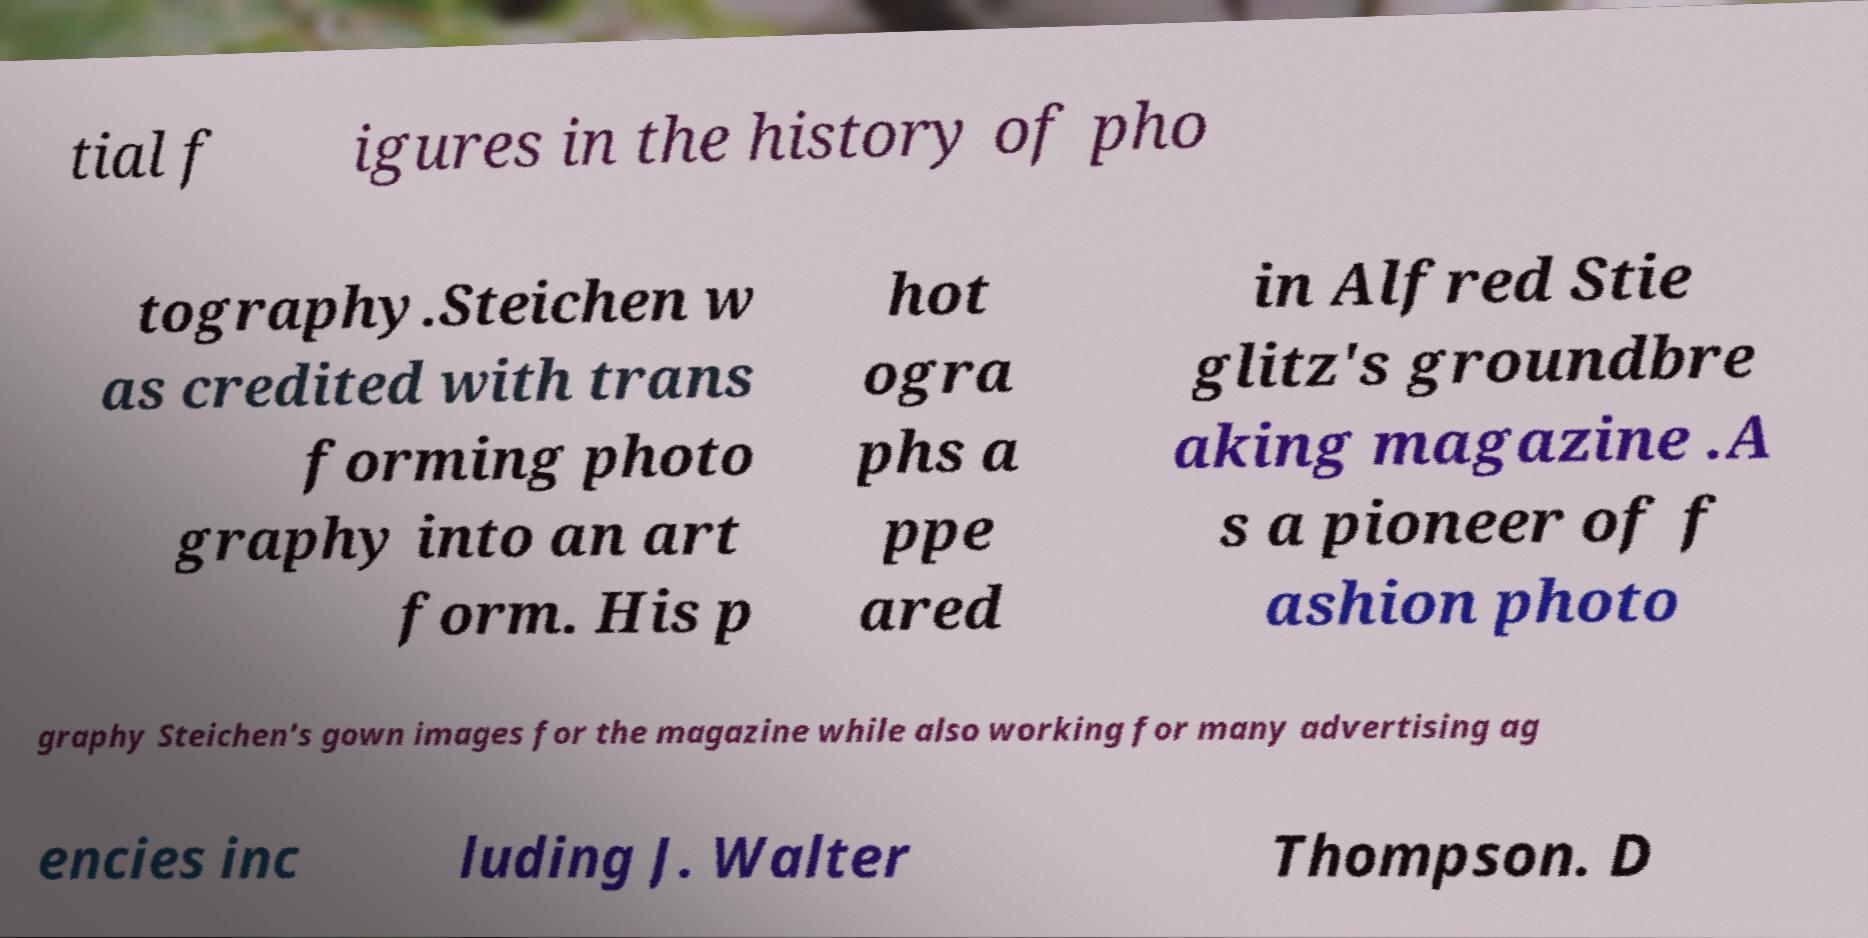What messages or text are displayed in this image? I need them in a readable, typed format. tial f igures in the history of pho tography.Steichen w as credited with trans forming photo graphy into an art form. His p hot ogra phs a ppe ared in Alfred Stie glitz's groundbre aking magazine .A s a pioneer of f ashion photo graphy Steichen's gown images for the magazine while also working for many advertising ag encies inc luding J. Walter Thompson. D 